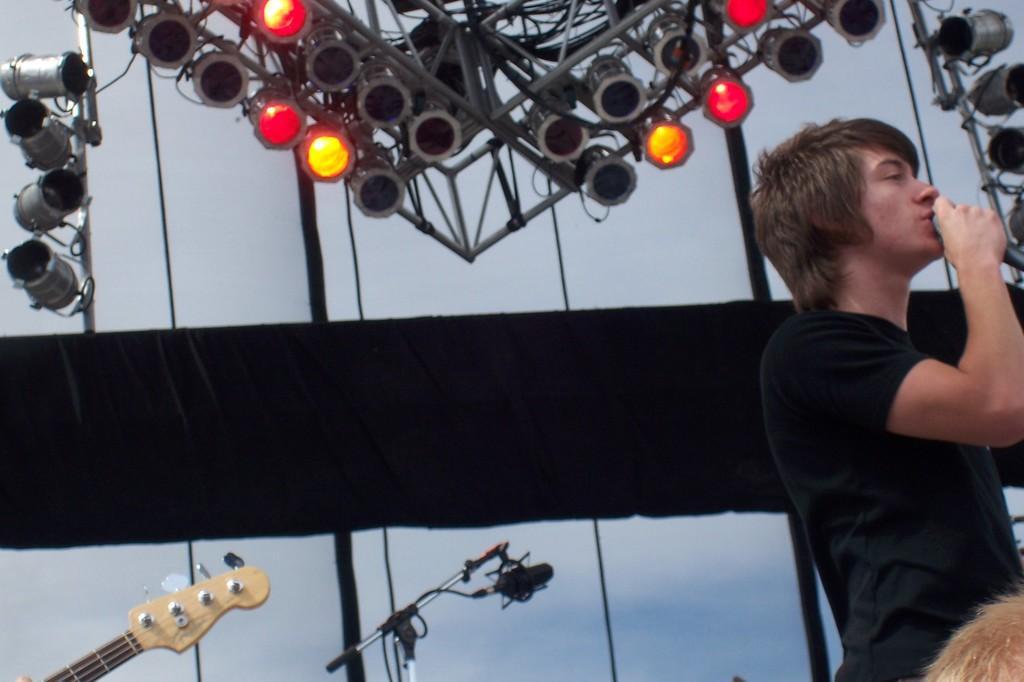Please provide a concise description of this image. In this picture there is a man standing and holding a microphone and singing. from the left there is a guitar, a microphone and its stand. To the top of the image there are spotlights. In the background there is wall. 